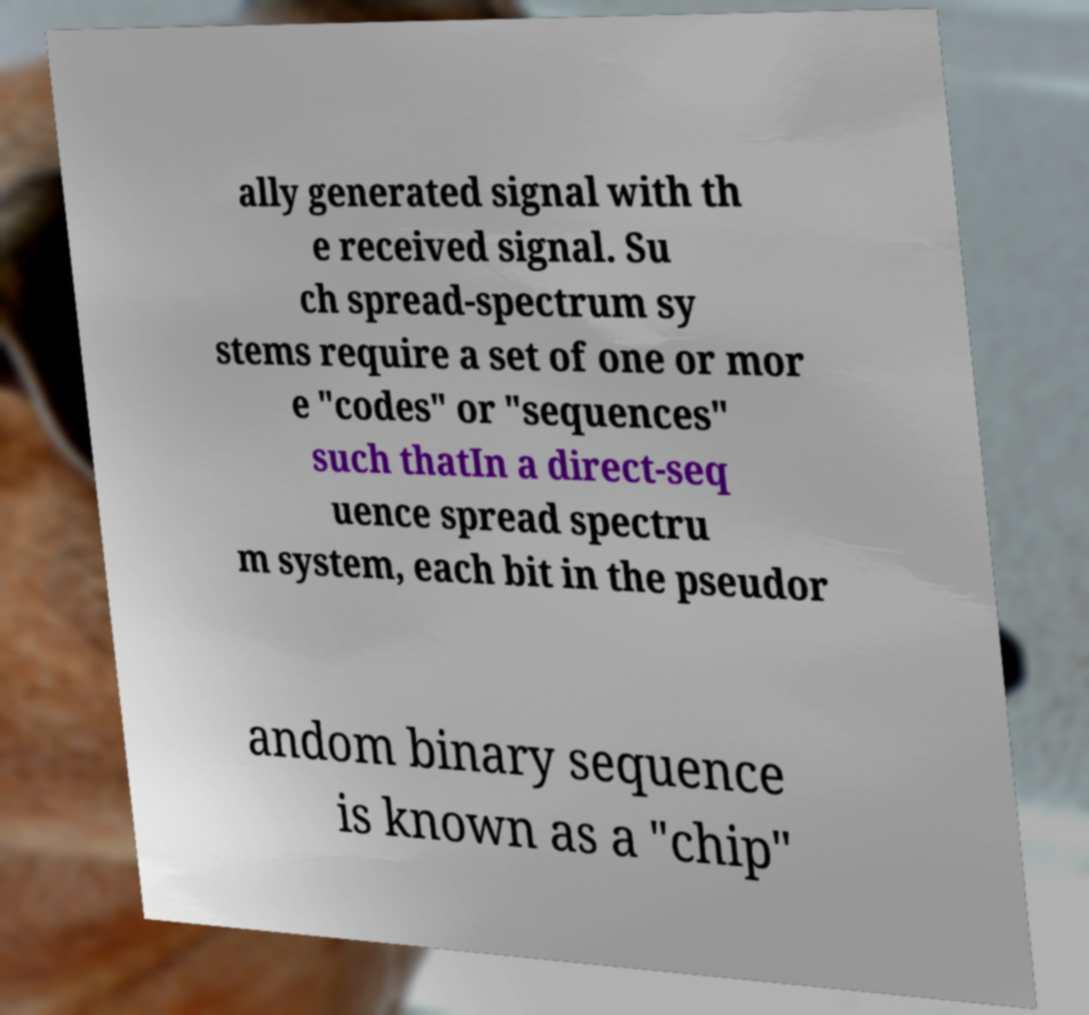Can you read and provide the text displayed in the image?This photo seems to have some interesting text. Can you extract and type it out for me? ally generated signal with th e received signal. Su ch spread-spectrum sy stems require a set of one or mor e "codes" or "sequences" such thatIn a direct-seq uence spread spectru m system, each bit in the pseudor andom binary sequence is known as a "chip" 